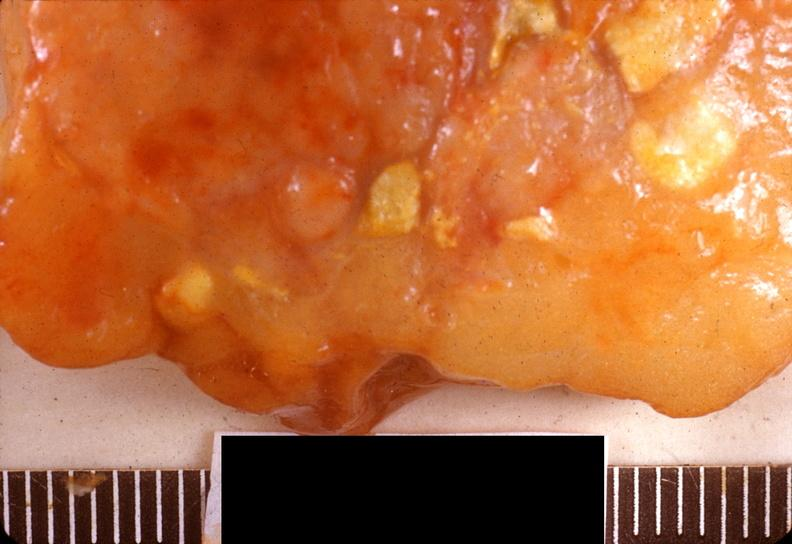what does this image show?
Answer the question using a single word or phrase. Acute pancreatitis 